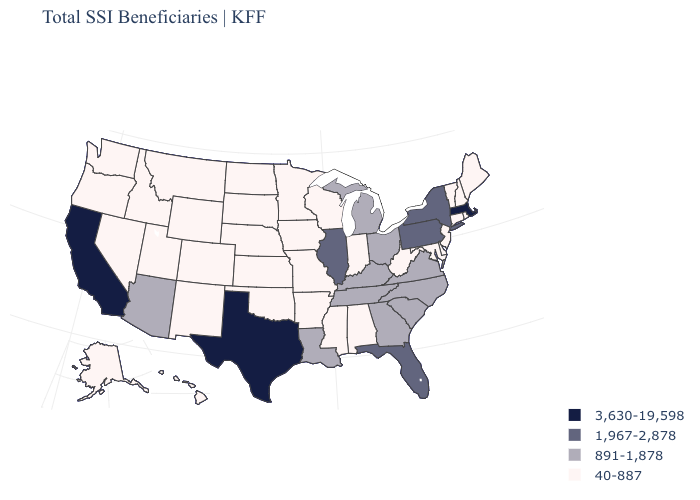Does West Virginia have the same value as Illinois?
Concise answer only. No. Does Massachusetts have the highest value in the USA?
Give a very brief answer. Yes. What is the value of Delaware?
Be succinct. 40-887. What is the highest value in states that border Mississippi?
Concise answer only. 891-1,878. Name the states that have a value in the range 891-1,878?
Short answer required. Arizona, Georgia, Kentucky, Louisiana, Michigan, North Carolina, Ohio, South Carolina, Tennessee, Virginia. Does Idaho have the lowest value in the West?
Quick response, please. Yes. Does the first symbol in the legend represent the smallest category?
Short answer required. No. What is the lowest value in the South?
Be succinct. 40-887. Which states have the highest value in the USA?
Short answer required. California, Massachusetts, Texas. Does the map have missing data?
Write a very short answer. No. Does North Dakota have the highest value in the MidWest?
Be succinct. No. What is the lowest value in the Northeast?
Keep it brief. 40-887. Which states hav the highest value in the MidWest?
Quick response, please. Illinois. Does Idaho have the same value as Illinois?
Write a very short answer. No. 